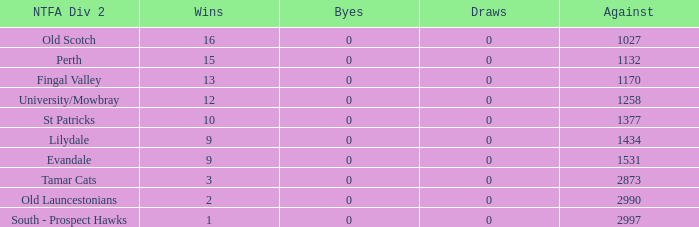What is the lowest number of against of NTFA Div 2 Fingal Valley? 1170.0. Could you help me parse every detail presented in this table? {'header': ['NTFA Div 2', 'Wins', 'Byes', 'Draws', 'Against'], 'rows': [['Old Scotch', '16', '0', '0', '1027'], ['Perth', '15', '0', '0', '1132'], ['Fingal Valley', '13', '0', '0', '1170'], ['University/Mowbray', '12', '0', '0', '1258'], ['St Patricks', '10', '0', '0', '1377'], ['Lilydale', '9', '0', '0', '1434'], ['Evandale', '9', '0', '0', '1531'], ['Tamar Cats', '3', '0', '0', '2873'], ['Old Launcestonians', '2', '0', '0', '2990'], ['South - Prospect Hawks', '1', '0', '0', '2997']]} 